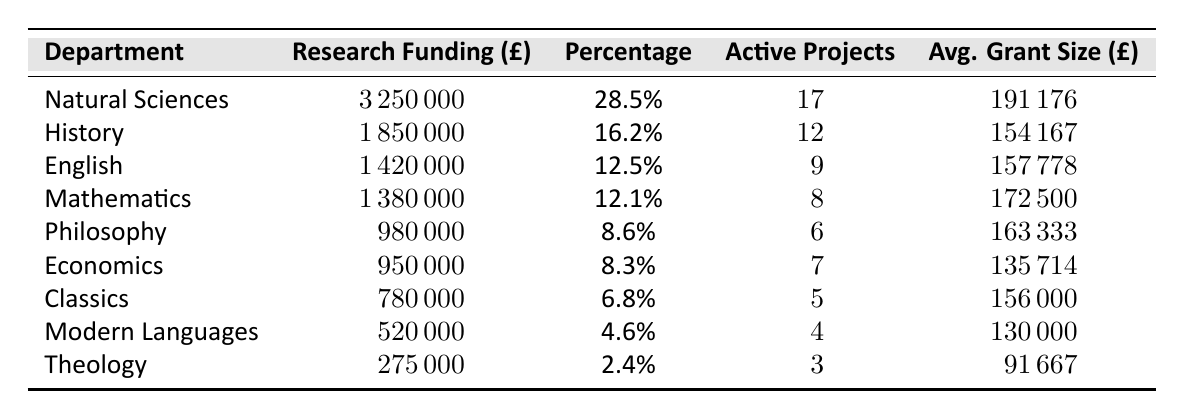What is the total research funding across all departments? To find the total research funding, we need to sum the values in the "Research Funding (£)" column: 3250000 + 1850000 + 1420000 + 1380000 + 980000 + 950000 + 780000 + 520000 + 275000 = 10282500.
Answer: 10282500 Which department received the highest research funding? By looking at the "Research Funding (£)" column, Natural Sciences has the highest value at 3250000.
Answer: Natural Sciences What percentage of total research funding does the Theology department represent? The percentage for the Theology department is given directly in the table as 2.4%.
Answer: 2.4% How many active projects are there in the Philosophy department? The number of active projects for the Philosophy department is listed as 6 in the table.
Answer: 6 What is the average grant size for Mathematics? The average grant size for Mathematics is provided directly as 172500 in the table.
Answer: 172500 Which department has the lowest average grant size? By comparing the "Average Grant Size (£)" values, Theology has the lowest at 91667.
Answer: Theology What is the difference in research funding between Natural Sciences and Theology? The research funding for Natural Sciences is 3250000 and for Theology is 275000. The difference is 3250000 - 275000 = 2975000.
Answer: 2975000 Which departments have more than 10 active projects? From the "Active Projects" column, Natural Sciences (17) and History (12) have more than 10 active projects.
Answer: Natural Sciences, History What is the average research funding for all departments? To find the average, sum all the research funding values (10282500) and divide by the number of departments (9): 10282500 / 9 = 1142500.
Answer: 1142500 Is the percentage of research funding for Mathematics higher than that for Economics? Mathematics has a percentage of 12.1% and Economics has 8.3%. Since 12.1% is greater than 8.3%, the statement is true.
Answer: Yes 